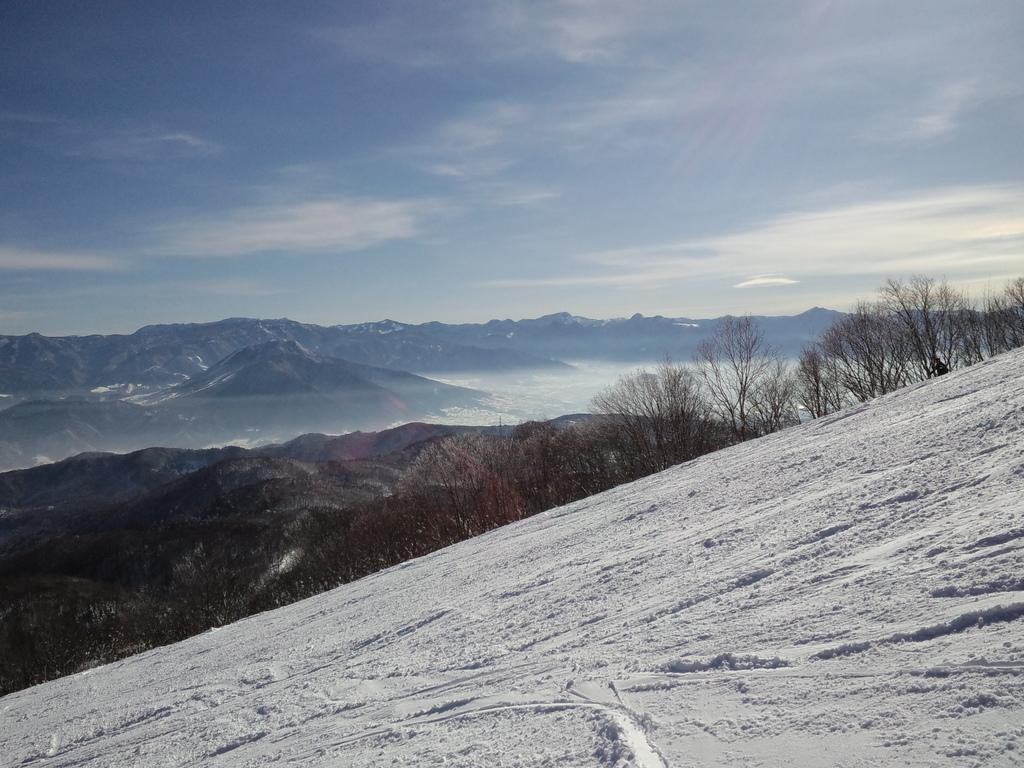Describe this image in one or two sentences. In this image I can see trees, water and mountains. At the top I can see the sky. This image is taken may be near the mountains. 